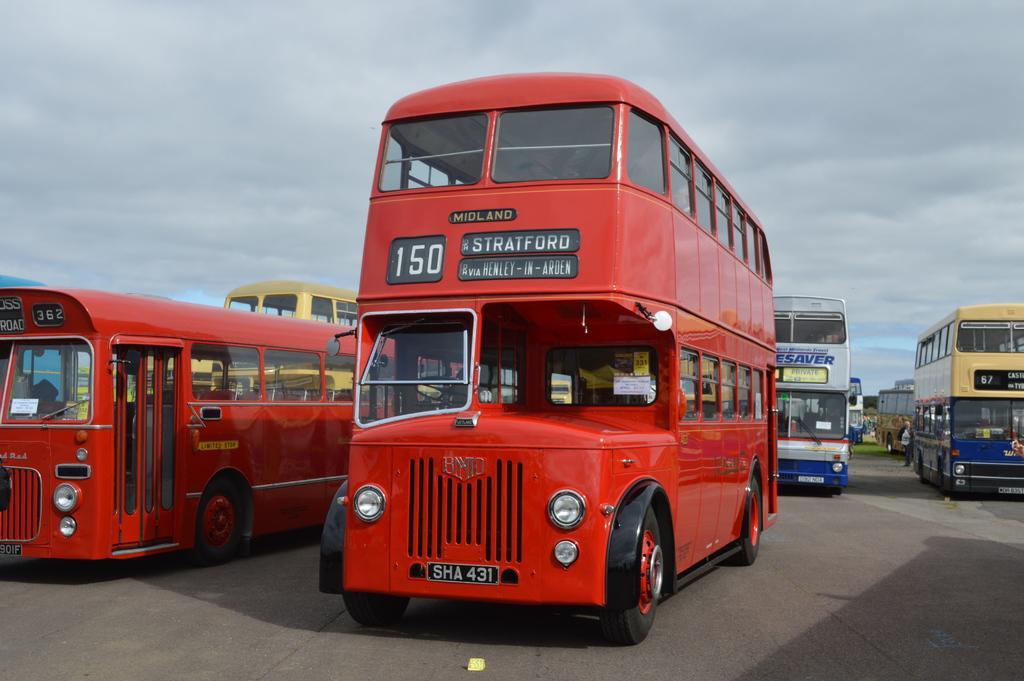Can you describe this image briefly? In this image we can see the vehicles parked on the path. In the background we can see the cloudy sky. 